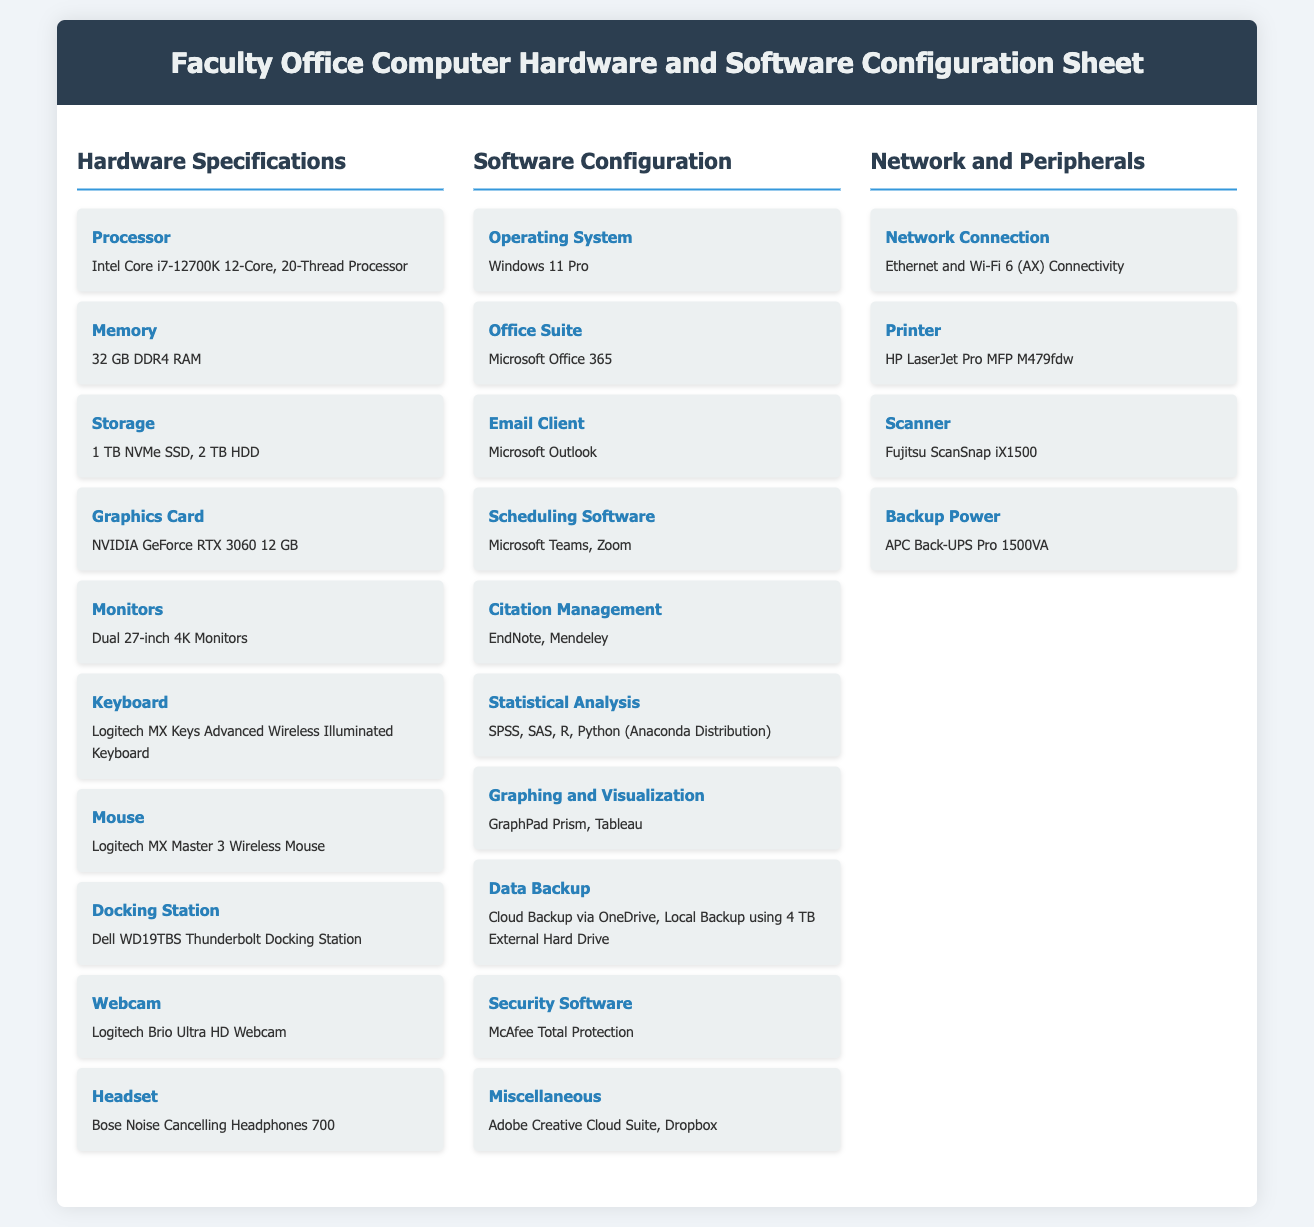What is the processor model? The processor model listed in the hardware specifications is a specific type of Intel processor that defines its capabilities and features.
Answer: Intel Core i7-12700K 12-Core, 20-Thread Processor How much RAM is included? The amount of RAM is specified as part of the hardware specifications for the faculty office computer, indicating its memory capacity.
Answer: 32 GB DDR4 RAM What is the storage type? The storage specifications detail the types of drives that are included in the computer's setup, along with their capacities.
Answer: 1 TB NVMe SSD, 2 TB HDD What operating system is installed? The operating system outlined is crucial for determining the compatibility and functionality of software applications in the office.
Answer: Windows 11 Pro Which email client is provided? The email client listed specifies the software used for communication, an essential tool for academic and professional correspondence.
Answer: Microsoft Outlook What is the statistical analysis software included? The inclusion of specific statistical analysis software indicates the computational capabilities available for data analysis tasks.
Answer: SPSS, SAS, R, Python (Anaconda Distribution) How many monitors are part of the configuration? The number of monitors specified in the configuration impacts the user's multitasking and productivity capabilities.
Answer: Dual 27-inch 4K Monitors What type of network connection is available? The type of network connection indicates the speed and connectivity options available for internet access and data transfer.
Answer: Ethernet and Wi-Fi 6 (AX) Connectivity What is the backup power solution? The backup power solution listed provides insight into the reliability of the setup in case of power interruptions.
Answer: APC Back-UPS Pro 1500VA 